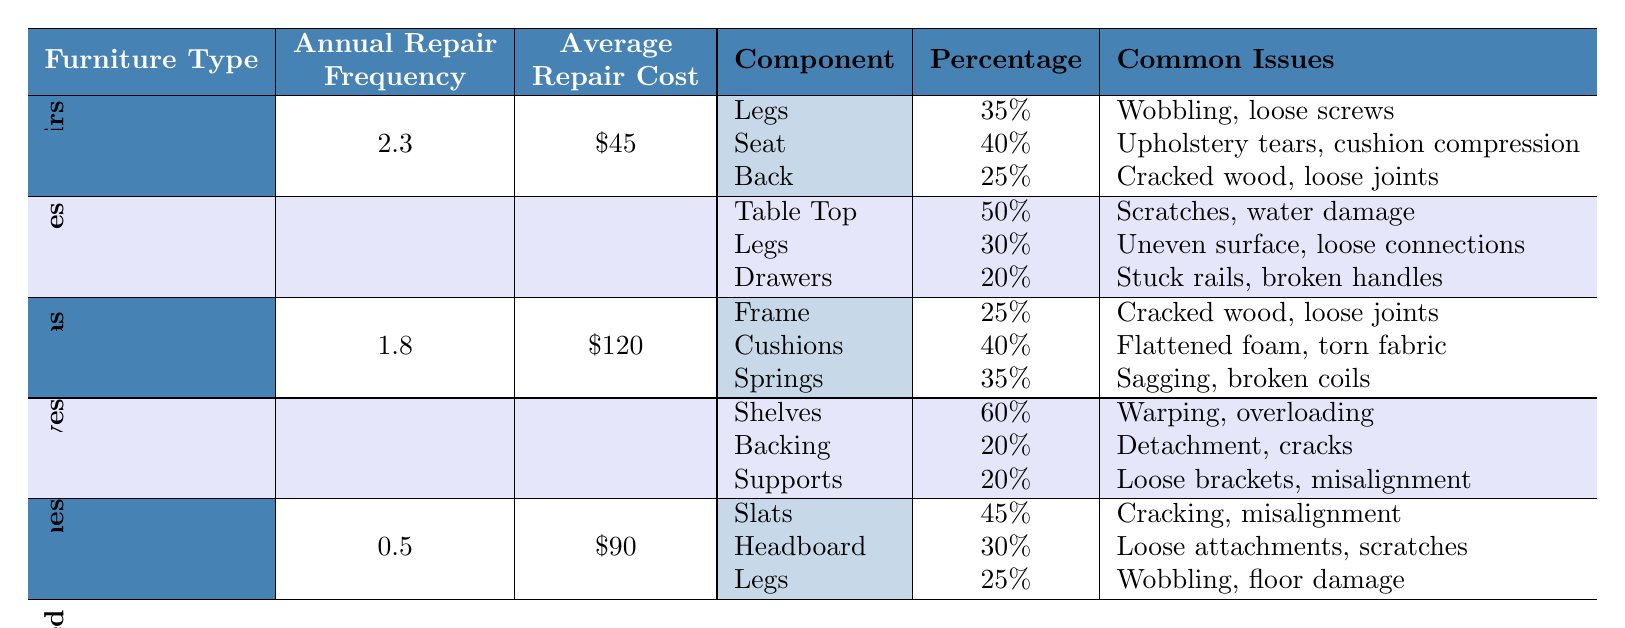What is the annual repair frequency for sofas? Referring to the table, the annual repair frequency for sofas is stated directly in the "Annual Repair Frequency" column for the "Sofas" row. It shows a value of 1.8.
Answer: 1.8 Which furniture type has the highest average repair cost? By comparing the values in the "Average Repair Cost" column, sofas have the highest average repair cost at $120 when compared to chairs ($45), tables ($75), bookshelves ($55), and bed frames ($90).
Answer: Sofas What percentage of repair costs for chairs is attributed to the seat component? Looking at the "Cost Breakdown" for chairs, the seat component accounts for 40% of the total repair costs as indicated in the table.
Answer: 40% How much higher is the average repair cost of sofas compared to bookshelves? To find this, subtract the average repair cost of bookshelves ($55) from that of sofas ($120). The difference is $120 - $55 = $65, indicating that sofas cost $65 more to repair on average.
Answer: $65 True or false: The legs of tables account for more repair cost percentage than the legs of chairs. For tables, the legs account for 30% of repair costs, while for chairs, the legs account for 35%. Since 30% is less than 35%, the statement is false.
Answer: False If you sum the annual repair frequencies of all furniture types, what is the total? Adding the values from the "Annual Repair Frequency" column: 2.3 (chairs) + 1.5 (tables) + 1.8 (sofas) + 0.8 (bookshelves) + 0.5 (bed frames) gives 2.3 + 1.5 + 1.8 + 0.8 + 0.5 = 8.1.
Answer: 8.1 Which furniture item has the least repair frequency and what is it? The least repair frequency is found in the bed frames row, where the frequency is 0.5, which is lower than all other furniture types listed.
Answer: Bed frames What are the common issues associated with the frames of sofas? The common issues associated with sofa frames are listed in the corresponding component section. It states that the common issues are cracked wood and loose joints.
Answer: Cracked wood, loose joints How many components contribute to the repair costs of chairs? The "Cost Breakdown" section for chairs lists three components: legs, seat, and back, indicating there are three components.
Answer: 3 What is the total percentage contribution of the shelves and backing in bookshelves? For bookshelves, the shelves contribute 60% and the backing contributes 20%. Adding these percentages gives 60% + 20% = 80%.
Answer: 80% 